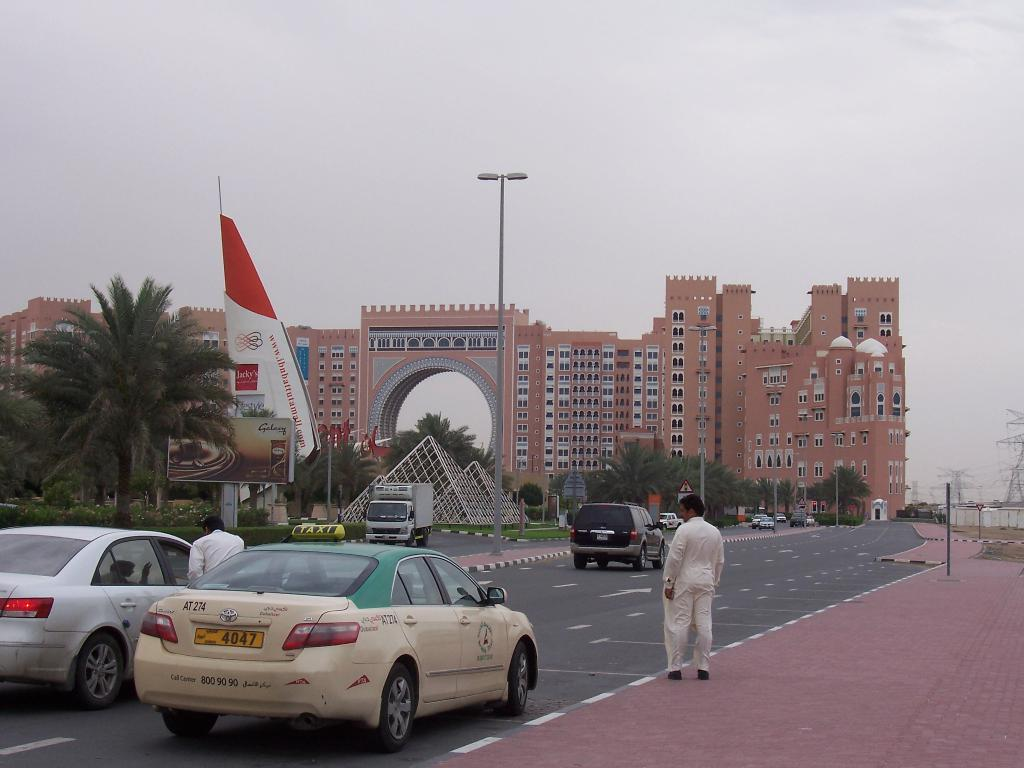Provide a one-sentence caption for the provided image. a toyota with license plate 4047 on the street headed towards the building. 